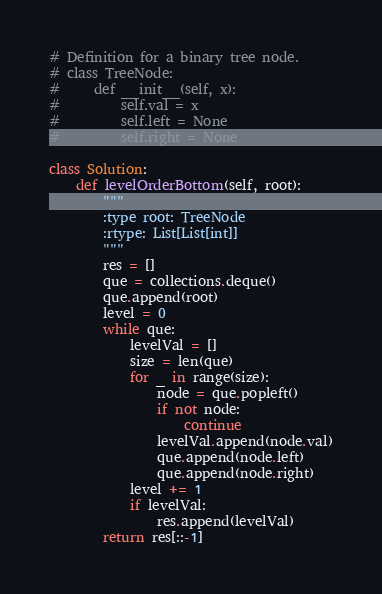<code> <loc_0><loc_0><loc_500><loc_500><_Python_># Definition for a binary tree node.
# class TreeNode:
#     def __init__(self, x):
#         self.val = x
#         self.left = None
#         self.right = None

class Solution:
    def levelOrderBottom(self, root):
        """
        :type root: TreeNode
        :rtype: List[List[int]]
        """
        res = []
        que = collections.deque()
        que.append(root)
        level = 0
        while que:
            levelVal = []
            size = len(que)
            for _ in range(size):
                node = que.popleft()
                if not node:
                    continue
                levelVal.append(node.val)
                que.append(node.left)
                que.append(node.right)
            level += 1
            if levelVal:
                res.append(levelVal)
        return res[::-1]
</code> 